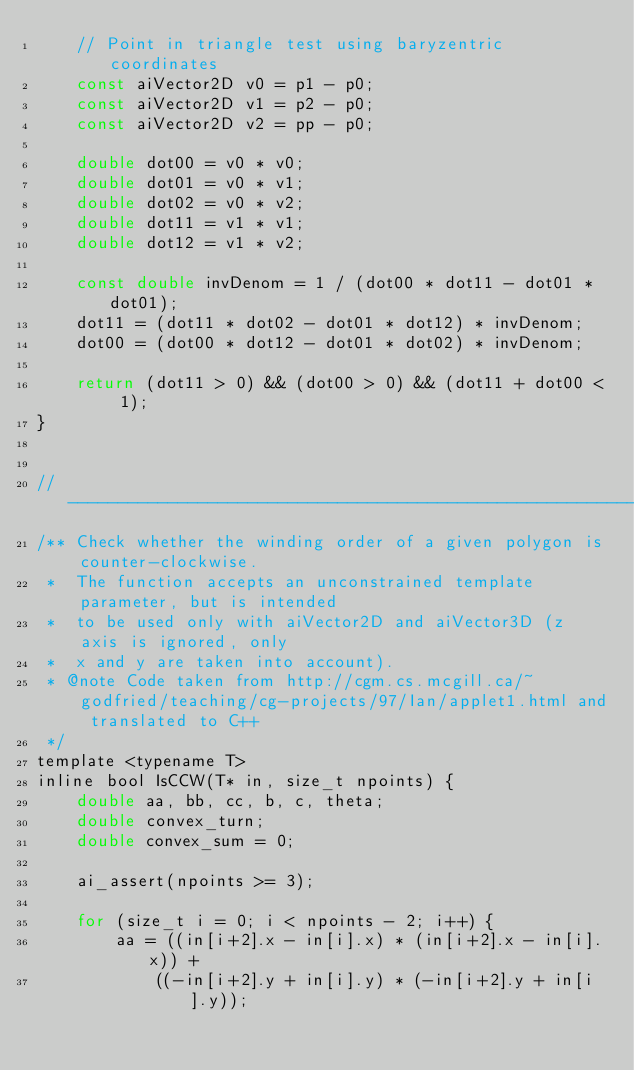<code> <loc_0><loc_0><loc_500><loc_500><_C_>	// Point in triangle test using baryzentric coordinates
	const aiVector2D v0 = p1 - p0;
	const aiVector2D v1 = p2 - p0;
	const aiVector2D v2 = pp - p0;

	double dot00 = v0 * v0;
	double dot01 = v0 * v1;
	double dot02 = v0 * v2;
	double dot11 = v1 * v1;
	double dot12 = v1 * v2;

	const double invDenom = 1 / (dot00 * dot11 - dot01 * dot01);
	dot11 = (dot11 * dot02 - dot01 * dot12) * invDenom;
	dot00 = (dot00 * dot12 - dot01 * dot02) * invDenom;

	return (dot11 > 0) && (dot00 > 0) && (dot11 + dot00 < 1);
}


// -------------------------------------------------------------------------------
/** Check whether the winding order of a given polygon is counter-clockwise.
 *  The function accepts an unconstrained template parameter, but is intended 
 *  to be used only with aiVector2D and aiVector3D (z axis is ignored, only
 *  x and y are taken into account).
 * @note Code taken from http://cgm.cs.mcgill.ca/~godfried/teaching/cg-projects/97/Ian/applet1.html and translated to C++
 */
template <typename T>
inline bool IsCCW(T* in, size_t npoints) {
	double aa, bb, cc, b, c, theta;
	double convex_turn;
	double convex_sum = 0;

	ai_assert(npoints >= 3);

	for (size_t i = 0; i < npoints - 2; i++) {		
		aa = ((in[i+2].x - in[i].x) * (in[i+2].x - in[i].x)) +
			((-in[i+2].y + in[i].y) * (-in[i+2].y + in[i].y));
</code> 